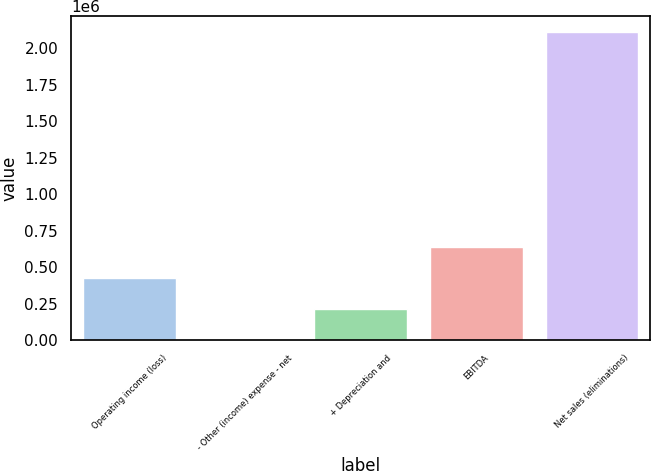Convert chart. <chart><loc_0><loc_0><loc_500><loc_500><bar_chart><fcel>Operating income (loss)<fcel>- Other (income) expense - net<fcel>+ Depreciation and<fcel>EBITDA<fcel>Net sales (eliminations)<nl><fcel>423993<fcel>1731<fcel>212862<fcel>635125<fcel>2.11304e+06<nl></chart> 